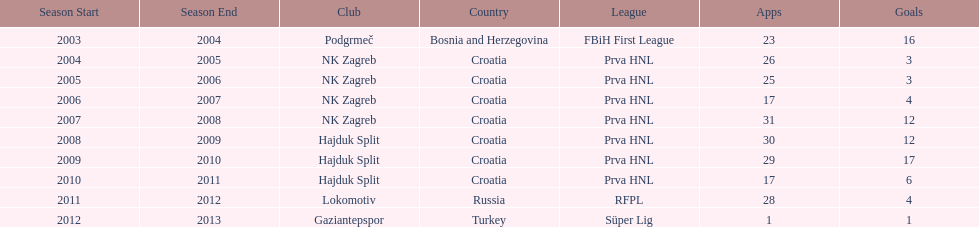What is the highest number of goals scored by senijad ibri&#269;i&#263; in a season? 35. 